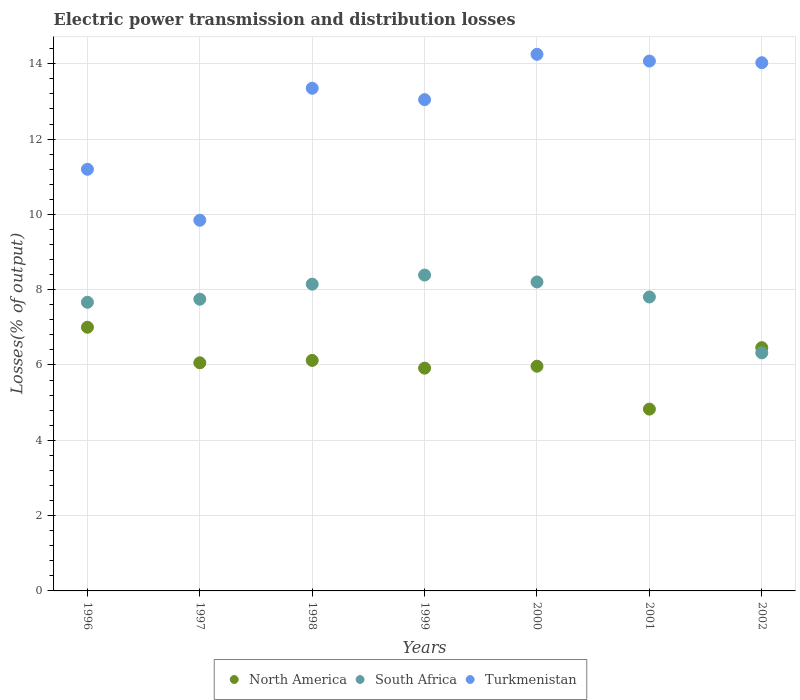Is the number of dotlines equal to the number of legend labels?
Give a very brief answer. Yes. What is the electric power transmission and distribution losses in Turkmenistan in 2002?
Your answer should be very brief. 14.03. Across all years, what is the maximum electric power transmission and distribution losses in South Africa?
Give a very brief answer. 8.39. Across all years, what is the minimum electric power transmission and distribution losses in Turkmenistan?
Your answer should be very brief. 9.84. In which year was the electric power transmission and distribution losses in North America maximum?
Offer a very short reply. 1996. What is the total electric power transmission and distribution losses in South Africa in the graph?
Offer a terse response. 54.28. What is the difference between the electric power transmission and distribution losses in South Africa in 1998 and that in 1999?
Offer a terse response. -0.24. What is the difference between the electric power transmission and distribution losses in North America in 2002 and the electric power transmission and distribution losses in South Africa in 1999?
Give a very brief answer. -1.93. What is the average electric power transmission and distribution losses in North America per year?
Provide a succinct answer. 6.05. In the year 1999, what is the difference between the electric power transmission and distribution losses in Turkmenistan and electric power transmission and distribution losses in North America?
Your answer should be very brief. 7.13. What is the ratio of the electric power transmission and distribution losses in North America in 1999 to that in 2000?
Keep it short and to the point. 0.99. Is the difference between the electric power transmission and distribution losses in Turkmenistan in 1996 and 1998 greater than the difference between the electric power transmission and distribution losses in North America in 1996 and 1998?
Keep it short and to the point. No. What is the difference between the highest and the second highest electric power transmission and distribution losses in South Africa?
Give a very brief answer. 0.18. What is the difference between the highest and the lowest electric power transmission and distribution losses in South Africa?
Ensure brevity in your answer.  2.07. Is it the case that in every year, the sum of the electric power transmission and distribution losses in South Africa and electric power transmission and distribution losses in North America  is greater than the electric power transmission and distribution losses in Turkmenistan?
Give a very brief answer. No. Does the electric power transmission and distribution losses in South Africa monotonically increase over the years?
Your answer should be very brief. No. Is the electric power transmission and distribution losses in North America strictly greater than the electric power transmission and distribution losses in Turkmenistan over the years?
Your response must be concise. No. Is the electric power transmission and distribution losses in North America strictly less than the electric power transmission and distribution losses in Turkmenistan over the years?
Offer a very short reply. Yes. How many dotlines are there?
Offer a very short reply. 3. Are the values on the major ticks of Y-axis written in scientific E-notation?
Ensure brevity in your answer.  No. What is the title of the graph?
Ensure brevity in your answer.  Electric power transmission and distribution losses. Does "Ecuador" appear as one of the legend labels in the graph?
Give a very brief answer. No. What is the label or title of the X-axis?
Offer a very short reply. Years. What is the label or title of the Y-axis?
Make the answer very short. Losses(% of output). What is the Losses(% of output) of North America in 1996?
Ensure brevity in your answer.  7. What is the Losses(% of output) of South Africa in 1996?
Your response must be concise. 7.67. What is the Losses(% of output) of Turkmenistan in 1996?
Offer a terse response. 11.2. What is the Losses(% of output) in North America in 1997?
Offer a terse response. 6.06. What is the Losses(% of output) of South Africa in 1997?
Give a very brief answer. 7.75. What is the Losses(% of output) in Turkmenistan in 1997?
Offer a terse response. 9.84. What is the Losses(% of output) of North America in 1998?
Make the answer very short. 6.12. What is the Losses(% of output) in South Africa in 1998?
Offer a very short reply. 8.15. What is the Losses(% of output) of Turkmenistan in 1998?
Provide a succinct answer. 13.35. What is the Losses(% of output) in North America in 1999?
Your response must be concise. 5.92. What is the Losses(% of output) in South Africa in 1999?
Ensure brevity in your answer.  8.39. What is the Losses(% of output) in Turkmenistan in 1999?
Offer a terse response. 13.05. What is the Losses(% of output) of North America in 2000?
Ensure brevity in your answer.  5.97. What is the Losses(% of output) of South Africa in 2000?
Your response must be concise. 8.2. What is the Losses(% of output) of Turkmenistan in 2000?
Your answer should be very brief. 14.25. What is the Losses(% of output) in North America in 2001?
Ensure brevity in your answer.  4.83. What is the Losses(% of output) of South Africa in 2001?
Ensure brevity in your answer.  7.81. What is the Losses(% of output) of Turkmenistan in 2001?
Provide a short and direct response. 14.07. What is the Losses(% of output) in North America in 2002?
Your answer should be very brief. 6.46. What is the Losses(% of output) in South Africa in 2002?
Offer a very short reply. 6.32. What is the Losses(% of output) of Turkmenistan in 2002?
Your answer should be very brief. 14.03. Across all years, what is the maximum Losses(% of output) in North America?
Your answer should be compact. 7. Across all years, what is the maximum Losses(% of output) of South Africa?
Give a very brief answer. 8.39. Across all years, what is the maximum Losses(% of output) in Turkmenistan?
Your response must be concise. 14.25. Across all years, what is the minimum Losses(% of output) in North America?
Offer a terse response. 4.83. Across all years, what is the minimum Losses(% of output) in South Africa?
Make the answer very short. 6.32. Across all years, what is the minimum Losses(% of output) in Turkmenistan?
Offer a terse response. 9.84. What is the total Losses(% of output) in North America in the graph?
Your response must be concise. 42.36. What is the total Losses(% of output) in South Africa in the graph?
Make the answer very short. 54.28. What is the total Losses(% of output) in Turkmenistan in the graph?
Offer a very short reply. 89.79. What is the difference between the Losses(% of output) of North America in 1996 and that in 1997?
Provide a short and direct response. 0.94. What is the difference between the Losses(% of output) of South Africa in 1996 and that in 1997?
Give a very brief answer. -0.08. What is the difference between the Losses(% of output) in Turkmenistan in 1996 and that in 1997?
Your answer should be very brief. 1.35. What is the difference between the Losses(% of output) of North America in 1996 and that in 1998?
Make the answer very short. 0.88. What is the difference between the Losses(% of output) of South Africa in 1996 and that in 1998?
Give a very brief answer. -0.48. What is the difference between the Losses(% of output) in Turkmenistan in 1996 and that in 1998?
Ensure brevity in your answer.  -2.15. What is the difference between the Losses(% of output) in North America in 1996 and that in 1999?
Your response must be concise. 1.09. What is the difference between the Losses(% of output) of South Africa in 1996 and that in 1999?
Your response must be concise. -0.72. What is the difference between the Losses(% of output) in Turkmenistan in 1996 and that in 1999?
Give a very brief answer. -1.85. What is the difference between the Losses(% of output) of North America in 1996 and that in 2000?
Offer a terse response. 1.03. What is the difference between the Losses(% of output) of South Africa in 1996 and that in 2000?
Your answer should be very brief. -0.54. What is the difference between the Losses(% of output) in Turkmenistan in 1996 and that in 2000?
Your response must be concise. -3.05. What is the difference between the Losses(% of output) in North America in 1996 and that in 2001?
Your answer should be compact. 2.17. What is the difference between the Losses(% of output) in South Africa in 1996 and that in 2001?
Keep it short and to the point. -0.14. What is the difference between the Losses(% of output) in Turkmenistan in 1996 and that in 2001?
Provide a short and direct response. -2.87. What is the difference between the Losses(% of output) in North America in 1996 and that in 2002?
Ensure brevity in your answer.  0.54. What is the difference between the Losses(% of output) of South Africa in 1996 and that in 2002?
Provide a succinct answer. 1.34. What is the difference between the Losses(% of output) of Turkmenistan in 1996 and that in 2002?
Make the answer very short. -2.83. What is the difference between the Losses(% of output) in North America in 1997 and that in 1998?
Your answer should be very brief. -0.06. What is the difference between the Losses(% of output) in South Africa in 1997 and that in 1998?
Your answer should be very brief. -0.4. What is the difference between the Losses(% of output) in Turkmenistan in 1997 and that in 1998?
Give a very brief answer. -3.51. What is the difference between the Losses(% of output) of North America in 1997 and that in 1999?
Give a very brief answer. 0.14. What is the difference between the Losses(% of output) of South Africa in 1997 and that in 1999?
Your answer should be compact. -0.64. What is the difference between the Losses(% of output) of Turkmenistan in 1997 and that in 1999?
Offer a terse response. -3.2. What is the difference between the Losses(% of output) in North America in 1997 and that in 2000?
Offer a very short reply. 0.09. What is the difference between the Losses(% of output) in South Africa in 1997 and that in 2000?
Provide a short and direct response. -0.46. What is the difference between the Losses(% of output) of Turkmenistan in 1997 and that in 2000?
Provide a succinct answer. -4.41. What is the difference between the Losses(% of output) of North America in 1997 and that in 2001?
Offer a very short reply. 1.23. What is the difference between the Losses(% of output) in South Africa in 1997 and that in 2001?
Give a very brief answer. -0.06. What is the difference between the Losses(% of output) of Turkmenistan in 1997 and that in 2001?
Your answer should be very brief. -4.23. What is the difference between the Losses(% of output) in North America in 1997 and that in 2002?
Provide a short and direct response. -0.4. What is the difference between the Losses(% of output) in South Africa in 1997 and that in 2002?
Offer a very short reply. 1.42. What is the difference between the Losses(% of output) of Turkmenistan in 1997 and that in 2002?
Offer a terse response. -4.18. What is the difference between the Losses(% of output) of North America in 1998 and that in 1999?
Ensure brevity in your answer.  0.2. What is the difference between the Losses(% of output) in South Africa in 1998 and that in 1999?
Ensure brevity in your answer.  -0.24. What is the difference between the Losses(% of output) in Turkmenistan in 1998 and that in 1999?
Provide a short and direct response. 0.3. What is the difference between the Losses(% of output) in North America in 1998 and that in 2000?
Keep it short and to the point. 0.15. What is the difference between the Losses(% of output) of South Africa in 1998 and that in 2000?
Ensure brevity in your answer.  -0.06. What is the difference between the Losses(% of output) of Turkmenistan in 1998 and that in 2000?
Provide a succinct answer. -0.9. What is the difference between the Losses(% of output) in North America in 1998 and that in 2001?
Give a very brief answer. 1.29. What is the difference between the Losses(% of output) in South Africa in 1998 and that in 2001?
Offer a terse response. 0.34. What is the difference between the Losses(% of output) of Turkmenistan in 1998 and that in 2001?
Your response must be concise. -0.72. What is the difference between the Losses(% of output) in North America in 1998 and that in 2002?
Offer a very short reply. -0.34. What is the difference between the Losses(% of output) in South Africa in 1998 and that in 2002?
Your response must be concise. 1.82. What is the difference between the Losses(% of output) of Turkmenistan in 1998 and that in 2002?
Offer a terse response. -0.68. What is the difference between the Losses(% of output) in North America in 1999 and that in 2000?
Ensure brevity in your answer.  -0.05. What is the difference between the Losses(% of output) of South Africa in 1999 and that in 2000?
Offer a very short reply. 0.18. What is the difference between the Losses(% of output) in Turkmenistan in 1999 and that in 2000?
Give a very brief answer. -1.2. What is the difference between the Losses(% of output) in North America in 1999 and that in 2001?
Provide a short and direct response. 1.09. What is the difference between the Losses(% of output) in South Africa in 1999 and that in 2001?
Make the answer very short. 0.58. What is the difference between the Losses(% of output) in Turkmenistan in 1999 and that in 2001?
Ensure brevity in your answer.  -1.02. What is the difference between the Losses(% of output) in North America in 1999 and that in 2002?
Provide a succinct answer. -0.54. What is the difference between the Losses(% of output) of South Africa in 1999 and that in 2002?
Your response must be concise. 2.07. What is the difference between the Losses(% of output) in Turkmenistan in 1999 and that in 2002?
Your answer should be compact. -0.98. What is the difference between the Losses(% of output) of North America in 2000 and that in 2001?
Ensure brevity in your answer.  1.14. What is the difference between the Losses(% of output) in South Africa in 2000 and that in 2001?
Ensure brevity in your answer.  0.4. What is the difference between the Losses(% of output) of Turkmenistan in 2000 and that in 2001?
Your response must be concise. 0.18. What is the difference between the Losses(% of output) of North America in 2000 and that in 2002?
Give a very brief answer. -0.49. What is the difference between the Losses(% of output) in South Africa in 2000 and that in 2002?
Offer a terse response. 1.88. What is the difference between the Losses(% of output) in Turkmenistan in 2000 and that in 2002?
Make the answer very short. 0.22. What is the difference between the Losses(% of output) of North America in 2001 and that in 2002?
Give a very brief answer. -1.63. What is the difference between the Losses(% of output) of South Africa in 2001 and that in 2002?
Offer a terse response. 1.48. What is the difference between the Losses(% of output) in Turkmenistan in 2001 and that in 2002?
Your answer should be very brief. 0.04. What is the difference between the Losses(% of output) of North America in 1996 and the Losses(% of output) of South Africa in 1997?
Give a very brief answer. -0.74. What is the difference between the Losses(% of output) of North America in 1996 and the Losses(% of output) of Turkmenistan in 1997?
Your answer should be compact. -2.84. What is the difference between the Losses(% of output) of South Africa in 1996 and the Losses(% of output) of Turkmenistan in 1997?
Offer a very short reply. -2.18. What is the difference between the Losses(% of output) of North America in 1996 and the Losses(% of output) of South Africa in 1998?
Ensure brevity in your answer.  -1.14. What is the difference between the Losses(% of output) in North America in 1996 and the Losses(% of output) in Turkmenistan in 1998?
Keep it short and to the point. -6.35. What is the difference between the Losses(% of output) of South Africa in 1996 and the Losses(% of output) of Turkmenistan in 1998?
Make the answer very short. -5.68. What is the difference between the Losses(% of output) of North America in 1996 and the Losses(% of output) of South Africa in 1999?
Offer a very short reply. -1.39. What is the difference between the Losses(% of output) of North America in 1996 and the Losses(% of output) of Turkmenistan in 1999?
Make the answer very short. -6.04. What is the difference between the Losses(% of output) of South Africa in 1996 and the Losses(% of output) of Turkmenistan in 1999?
Your answer should be very brief. -5.38. What is the difference between the Losses(% of output) of North America in 1996 and the Losses(% of output) of South Africa in 2000?
Give a very brief answer. -1.2. What is the difference between the Losses(% of output) in North America in 1996 and the Losses(% of output) in Turkmenistan in 2000?
Your response must be concise. -7.25. What is the difference between the Losses(% of output) in South Africa in 1996 and the Losses(% of output) in Turkmenistan in 2000?
Your response must be concise. -6.58. What is the difference between the Losses(% of output) of North America in 1996 and the Losses(% of output) of South Africa in 2001?
Provide a short and direct response. -0.8. What is the difference between the Losses(% of output) in North America in 1996 and the Losses(% of output) in Turkmenistan in 2001?
Give a very brief answer. -7.07. What is the difference between the Losses(% of output) of South Africa in 1996 and the Losses(% of output) of Turkmenistan in 2001?
Your answer should be compact. -6.41. What is the difference between the Losses(% of output) in North America in 1996 and the Losses(% of output) in South Africa in 2002?
Ensure brevity in your answer.  0.68. What is the difference between the Losses(% of output) of North America in 1996 and the Losses(% of output) of Turkmenistan in 2002?
Your answer should be very brief. -7.03. What is the difference between the Losses(% of output) in South Africa in 1996 and the Losses(% of output) in Turkmenistan in 2002?
Provide a short and direct response. -6.36. What is the difference between the Losses(% of output) of North America in 1997 and the Losses(% of output) of South Africa in 1998?
Your response must be concise. -2.09. What is the difference between the Losses(% of output) in North America in 1997 and the Losses(% of output) in Turkmenistan in 1998?
Your answer should be compact. -7.29. What is the difference between the Losses(% of output) of South Africa in 1997 and the Losses(% of output) of Turkmenistan in 1998?
Your answer should be very brief. -5.6. What is the difference between the Losses(% of output) in North America in 1997 and the Losses(% of output) in South Africa in 1999?
Your answer should be compact. -2.33. What is the difference between the Losses(% of output) in North America in 1997 and the Losses(% of output) in Turkmenistan in 1999?
Provide a succinct answer. -6.99. What is the difference between the Losses(% of output) in South Africa in 1997 and the Losses(% of output) in Turkmenistan in 1999?
Your answer should be very brief. -5.3. What is the difference between the Losses(% of output) in North America in 1997 and the Losses(% of output) in South Africa in 2000?
Your answer should be compact. -2.15. What is the difference between the Losses(% of output) of North America in 1997 and the Losses(% of output) of Turkmenistan in 2000?
Make the answer very short. -8.19. What is the difference between the Losses(% of output) of South Africa in 1997 and the Losses(% of output) of Turkmenistan in 2000?
Make the answer very short. -6.5. What is the difference between the Losses(% of output) of North America in 1997 and the Losses(% of output) of South Africa in 2001?
Make the answer very short. -1.75. What is the difference between the Losses(% of output) in North America in 1997 and the Losses(% of output) in Turkmenistan in 2001?
Offer a terse response. -8.01. What is the difference between the Losses(% of output) in South Africa in 1997 and the Losses(% of output) in Turkmenistan in 2001?
Your response must be concise. -6.33. What is the difference between the Losses(% of output) of North America in 1997 and the Losses(% of output) of South Africa in 2002?
Provide a succinct answer. -0.26. What is the difference between the Losses(% of output) in North America in 1997 and the Losses(% of output) in Turkmenistan in 2002?
Provide a succinct answer. -7.97. What is the difference between the Losses(% of output) in South Africa in 1997 and the Losses(% of output) in Turkmenistan in 2002?
Keep it short and to the point. -6.28. What is the difference between the Losses(% of output) of North America in 1998 and the Losses(% of output) of South Africa in 1999?
Ensure brevity in your answer.  -2.27. What is the difference between the Losses(% of output) of North America in 1998 and the Losses(% of output) of Turkmenistan in 1999?
Offer a terse response. -6.93. What is the difference between the Losses(% of output) in South Africa in 1998 and the Losses(% of output) in Turkmenistan in 1999?
Ensure brevity in your answer.  -4.9. What is the difference between the Losses(% of output) in North America in 1998 and the Losses(% of output) in South Africa in 2000?
Ensure brevity in your answer.  -2.08. What is the difference between the Losses(% of output) of North America in 1998 and the Losses(% of output) of Turkmenistan in 2000?
Your answer should be compact. -8.13. What is the difference between the Losses(% of output) of South Africa in 1998 and the Losses(% of output) of Turkmenistan in 2000?
Offer a very short reply. -6.1. What is the difference between the Losses(% of output) of North America in 1998 and the Losses(% of output) of South Africa in 2001?
Your response must be concise. -1.68. What is the difference between the Losses(% of output) of North America in 1998 and the Losses(% of output) of Turkmenistan in 2001?
Give a very brief answer. -7.95. What is the difference between the Losses(% of output) in South Africa in 1998 and the Losses(% of output) in Turkmenistan in 2001?
Provide a short and direct response. -5.92. What is the difference between the Losses(% of output) in North America in 1998 and the Losses(% of output) in South Africa in 2002?
Your response must be concise. -0.2. What is the difference between the Losses(% of output) in North America in 1998 and the Losses(% of output) in Turkmenistan in 2002?
Offer a terse response. -7.91. What is the difference between the Losses(% of output) in South Africa in 1998 and the Losses(% of output) in Turkmenistan in 2002?
Provide a short and direct response. -5.88. What is the difference between the Losses(% of output) in North America in 1999 and the Losses(% of output) in South Africa in 2000?
Keep it short and to the point. -2.29. What is the difference between the Losses(% of output) of North America in 1999 and the Losses(% of output) of Turkmenistan in 2000?
Make the answer very short. -8.33. What is the difference between the Losses(% of output) in South Africa in 1999 and the Losses(% of output) in Turkmenistan in 2000?
Make the answer very short. -5.86. What is the difference between the Losses(% of output) of North America in 1999 and the Losses(% of output) of South Africa in 2001?
Make the answer very short. -1.89. What is the difference between the Losses(% of output) of North America in 1999 and the Losses(% of output) of Turkmenistan in 2001?
Offer a very short reply. -8.15. What is the difference between the Losses(% of output) of South Africa in 1999 and the Losses(% of output) of Turkmenistan in 2001?
Make the answer very short. -5.68. What is the difference between the Losses(% of output) of North America in 1999 and the Losses(% of output) of South Africa in 2002?
Ensure brevity in your answer.  -0.41. What is the difference between the Losses(% of output) in North America in 1999 and the Losses(% of output) in Turkmenistan in 2002?
Ensure brevity in your answer.  -8.11. What is the difference between the Losses(% of output) of South Africa in 1999 and the Losses(% of output) of Turkmenistan in 2002?
Provide a short and direct response. -5.64. What is the difference between the Losses(% of output) of North America in 2000 and the Losses(% of output) of South Africa in 2001?
Provide a succinct answer. -1.84. What is the difference between the Losses(% of output) in North America in 2000 and the Losses(% of output) in Turkmenistan in 2001?
Offer a very short reply. -8.1. What is the difference between the Losses(% of output) in South Africa in 2000 and the Losses(% of output) in Turkmenistan in 2001?
Keep it short and to the point. -5.87. What is the difference between the Losses(% of output) in North America in 2000 and the Losses(% of output) in South Africa in 2002?
Make the answer very short. -0.36. What is the difference between the Losses(% of output) of North America in 2000 and the Losses(% of output) of Turkmenistan in 2002?
Make the answer very short. -8.06. What is the difference between the Losses(% of output) in South Africa in 2000 and the Losses(% of output) in Turkmenistan in 2002?
Offer a very short reply. -5.82. What is the difference between the Losses(% of output) in North America in 2001 and the Losses(% of output) in South Africa in 2002?
Your answer should be very brief. -1.5. What is the difference between the Losses(% of output) of North America in 2001 and the Losses(% of output) of Turkmenistan in 2002?
Ensure brevity in your answer.  -9.2. What is the difference between the Losses(% of output) in South Africa in 2001 and the Losses(% of output) in Turkmenistan in 2002?
Offer a very short reply. -6.22. What is the average Losses(% of output) of North America per year?
Give a very brief answer. 6.05. What is the average Losses(% of output) of South Africa per year?
Ensure brevity in your answer.  7.75. What is the average Losses(% of output) of Turkmenistan per year?
Give a very brief answer. 12.83. In the year 1996, what is the difference between the Losses(% of output) in North America and Losses(% of output) in South Africa?
Your response must be concise. -0.66. In the year 1996, what is the difference between the Losses(% of output) of North America and Losses(% of output) of Turkmenistan?
Provide a short and direct response. -4.2. In the year 1996, what is the difference between the Losses(% of output) of South Africa and Losses(% of output) of Turkmenistan?
Your response must be concise. -3.53. In the year 1997, what is the difference between the Losses(% of output) in North America and Losses(% of output) in South Africa?
Your answer should be compact. -1.69. In the year 1997, what is the difference between the Losses(% of output) in North America and Losses(% of output) in Turkmenistan?
Offer a very short reply. -3.79. In the year 1997, what is the difference between the Losses(% of output) in South Africa and Losses(% of output) in Turkmenistan?
Ensure brevity in your answer.  -2.1. In the year 1998, what is the difference between the Losses(% of output) of North America and Losses(% of output) of South Africa?
Make the answer very short. -2.03. In the year 1998, what is the difference between the Losses(% of output) of North America and Losses(% of output) of Turkmenistan?
Your answer should be compact. -7.23. In the year 1998, what is the difference between the Losses(% of output) in South Africa and Losses(% of output) in Turkmenistan?
Your response must be concise. -5.2. In the year 1999, what is the difference between the Losses(% of output) of North America and Losses(% of output) of South Africa?
Keep it short and to the point. -2.47. In the year 1999, what is the difference between the Losses(% of output) of North America and Losses(% of output) of Turkmenistan?
Your response must be concise. -7.13. In the year 1999, what is the difference between the Losses(% of output) in South Africa and Losses(% of output) in Turkmenistan?
Your answer should be compact. -4.66. In the year 2000, what is the difference between the Losses(% of output) of North America and Losses(% of output) of South Africa?
Make the answer very short. -2.24. In the year 2000, what is the difference between the Losses(% of output) in North America and Losses(% of output) in Turkmenistan?
Your response must be concise. -8.28. In the year 2000, what is the difference between the Losses(% of output) of South Africa and Losses(% of output) of Turkmenistan?
Offer a terse response. -6.05. In the year 2001, what is the difference between the Losses(% of output) in North America and Losses(% of output) in South Africa?
Provide a short and direct response. -2.98. In the year 2001, what is the difference between the Losses(% of output) in North America and Losses(% of output) in Turkmenistan?
Offer a terse response. -9.24. In the year 2001, what is the difference between the Losses(% of output) of South Africa and Losses(% of output) of Turkmenistan?
Provide a short and direct response. -6.27. In the year 2002, what is the difference between the Losses(% of output) of North America and Losses(% of output) of South Africa?
Provide a succinct answer. 0.14. In the year 2002, what is the difference between the Losses(% of output) of North America and Losses(% of output) of Turkmenistan?
Your response must be concise. -7.57. In the year 2002, what is the difference between the Losses(% of output) of South Africa and Losses(% of output) of Turkmenistan?
Make the answer very short. -7.7. What is the ratio of the Losses(% of output) of North America in 1996 to that in 1997?
Provide a short and direct response. 1.16. What is the ratio of the Losses(% of output) of South Africa in 1996 to that in 1997?
Your answer should be very brief. 0.99. What is the ratio of the Losses(% of output) in Turkmenistan in 1996 to that in 1997?
Ensure brevity in your answer.  1.14. What is the ratio of the Losses(% of output) of North America in 1996 to that in 1998?
Make the answer very short. 1.14. What is the ratio of the Losses(% of output) of South Africa in 1996 to that in 1998?
Offer a very short reply. 0.94. What is the ratio of the Losses(% of output) in Turkmenistan in 1996 to that in 1998?
Give a very brief answer. 0.84. What is the ratio of the Losses(% of output) of North America in 1996 to that in 1999?
Keep it short and to the point. 1.18. What is the ratio of the Losses(% of output) in South Africa in 1996 to that in 1999?
Provide a short and direct response. 0.91. What is the ratio of the Losses(% of output) in Turkmenistan in 1996 to that in 1999?
Give a very brief answer. 0.86. What is the ratio of the Losses(% of output) of North America in 1996 to that in 2000?
Ensure brevity in your answer.  1.17. What is the ratio of the Losses(% of output) in South Africa in 1996 to that in 2000?
Keep it short and to the point. 0.93. What is the ratio of the Losses(% of output) in Turkmenistan in 1996 to that in 2000?
Ensure brevity in your answer.  0.79. What is the ratio of the Losses(% of output) of North America in 1996 to that in 2001?
Offer a very short reply. 1.45. What is the ratio of the Losses(% of output) of Turkmenistan in 1996 to that in 2001?
Keep it short and to the point. 0.8. What is the ratio of the Losses(% of output) of North America in 1996 to that in 2002?
Provide a succinct answer. 1.08. What is the ratio of the Losses(% of output) of South Africa in 1996 to that in 2002?
Keep it short and to the point. 1.21. What is the ratio of the Losses(% of output) in Turkmenistan in 1996 to that in 2002?
Provide a succinct answer. 0.8. What is the ratio of the Losses(% of output) of South Africa in 1997 to that in 1998?
Keep it short and to the point. 0.95. What is the ratio of the Losses(% of output) of Turkmenistan in 1997 to that in 1998?
Ensure brevity in your answer.  0.74. What is the ratio of the Losses(% of output) of North America in 1997 to that in 1999?
Provide a short and direct response. 1.02. What is the ratio of the Losses(% of output) in South Africa in 1997 to that in 1999?
Offer a very short reply. 0.92. What is the ratio of the Losses(% of output) in Turkmenistan in 1997 to that in 1999?
Your response must be concise. 0.75. What is the ratio of the Losses(% of output) in North America in 1997 to that in 2000?
Offer a terse response. 1.02. What is the ratio of the Losses(% of output) in South Africa in 1997 to that in 2000?
Your response must be concise. 0.94. What is the ratio of the Losses(% of output) in Turkmenistan in 1997 to that in 2000?
Your answer should be compact. 0.69. What is the ratio of the Losses(% of output) in North America in 1997 to that in 2001?
Your answer should be compact. 1.25. What is the ratio of the Losses(% of output) of South Africa in 1997 to that in 2001?
Your response must be concise. 0.99. What is the ratio of the Losses(% of output) in Turkmenistan in 1997 to that in 2001?
Offer a terse response. 0.7. What is the ratio of the Losses(% of output) of North America in 1997 to that in 2002?
Your answer should be compact. 0.94. What is the ratio of the Losses(% of output) in South Africa in 1997 to that in 2002?
Give a very brief answer. 1.23. What is the ratio of the Losses(% of output) in Turkmenistan in 1997 to that in 2002?
Offer a very short reply. 0.7. What is the ratio of the Losses(% of output) of North America in 1998 to that in 1999?
Give a very brief answer. 1.03. What is the ratio of the Losses(% of output) in South Africa in 1998 to that in 1999?
Your answer should be very brief. 0.97. What is the ratio of the Losses(% of output) in Turkmenistan in 1998 to that in 1999?
Ensure brevity in your answer.  1.02. What is the ratio of the Losses(% of output) of North America in 1998 to that in 2000?
Make the answer very short. 1.03. What is the ratio of the Losses(% of output) of Turkmenistan in 1998 to that in 2000?
Ensure brevity in your answer.  0.94. What is the ratio of the Losses(% of output) of North America in 1998 to that in 2001?
Provide a succinct answer. 1.27. What is the ratio of the Losses(% of output) of South Africa in 1998 to that in 2001?
Make the answer very short. 1.04. What is the ratio of the Losses(% of output) in Turkmenistan in 1998 to that in 2001?
Your answer should be very brief. 0.95. What is the ratio of the Losses(% of output) of North America in 1998 to that in 2002?
Provide a short and direct response. 0.95. What is the ratio of the Losses(% of output) of South Africa in 1998 to that in 2002?
Give a very brief answer. 1.29. What is the ratio of the Losses(% of output) in Turkmenistan in 1998 to that in 2002?
Make the answer very short. 0.95. What is the ratio of the Losses(% of output) in North America in 1999 to that in 2000?
Offer a very short reply. 0.99. What is the ratio of the Losses(% of output) of South Africa in 1999 to that in 2000?
Provide a short and direct response. 1.02. What is the ratio of the Losses(% of output) in Turkmenistan in 1999 to that in 2000?
Your answer should be compact. 0.92. What is the ratio of the Losses(% of output) in North America in 1999 to that in 2001?
Offer a very short reply. 1.23. What is the ratio of the Losses(% of output) in South Africa in 1999 to that in 2001?
Keep it short and to the point. 1.07. What is the ratio of the Losses(% of output) of Turkmenistan in 1999 to that in 2001?
Make the answer very short. 0.93. What is the ratio of the Losses(% of output) of North America in 1999 to that in 2002?
Offer a very short reply. 0.92. What is the ratio of the Losses(% of output) of South Africa in 1999 to that in 2002?
Provide a succinct answer. 1.33. What is the ratio of the Losses(% of output) of Turkmenistan in 1999 to that in 2002?
Give a very brief answer. 0.93. What is the ratio of the Losses(% of output) of North America in 2000 to that in 2001?
Your answer should be very brief. 1.24. What is the ratio of the Losses(% of output) of South Africa in 2000 to that in 2001?
Provide a succinct answer. 1.05. What is the ratio of the Losses(% of output) of Turkmenistan in 2000 to that in 2001?
Offer a terse response. 1.01. What is the ratio of the Losses(% of output) in North America in 2000 to that in 2002?
Provide a succinct answer. 0.92. What is the ratio of the Losses(% of output) in South Africa in 2000 to that in 2002?
Give a very brief answer. 1.3. What is the ratio of the Losses(% of output) of Turkmenistan in 2000 to that in 2002?
Provide a short and direct response. 1.02. What is the ratio of the Losses(% of output) of North America in 2001 to that in 2002?
Offer a very short reply. 0.75. What is the ratio of the Losses(% of output) of South Africa in 2001 to that in 2002?
Make the answer very short. 1.23. What is the ratio of the Losses(% of output) in Turkmenistan in 2001 to that in 2002?
Offer a terse response. 1. What is the difference between the highest and the second highest Losses(% of output) of North America?
Provide a succinct answer. 0.54. What is the difference between the highest and the second highest Losses(% of output) of South Africa?
Your answer should be compact. 0.18. What is the difference between the highest and the second highest Losses(% of output) in Turkmenistan?
Your answer should be compact. 0.18. What is the difference between the highest and the lowest Losses(% of output) of North America?
Ensure brevity in your answer.  2.17. What is the difference between the highest and the lowest Losses(% of output) in South Africa?
Your answer should be very brief. 2.07. What is the difference between the highest and the lowest Losses(% of output) in Turkmenistan?
Give a very brief answer. 4.41. 